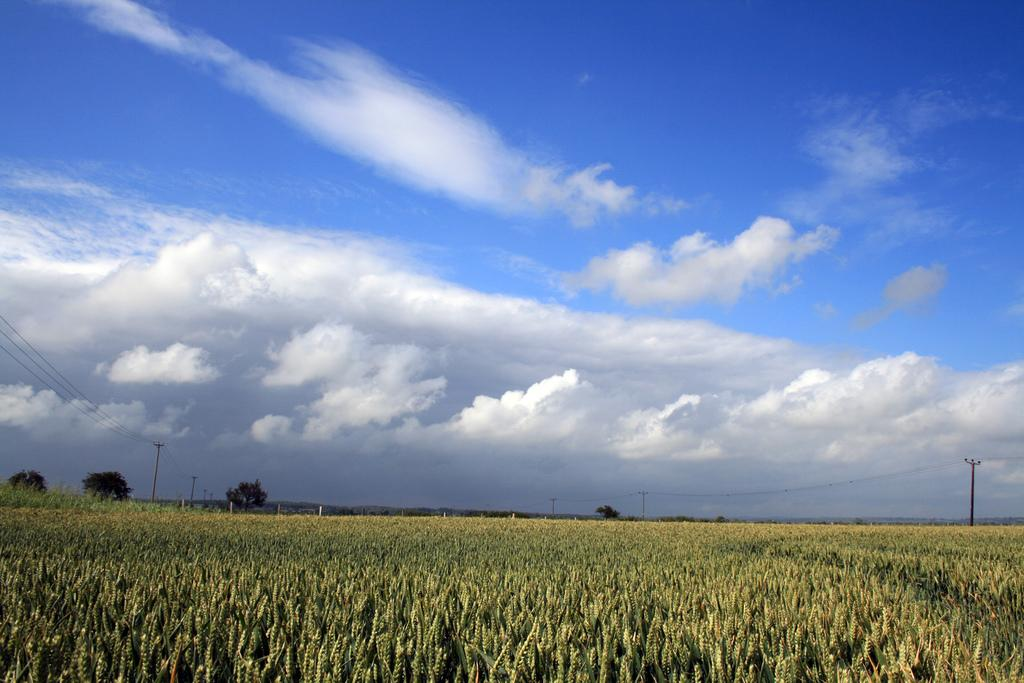What type of landscape is at the bottom of the image? There is a field at the bottom of the image. What can be seen in the background of the image? There are trees, poles, and hills in the background of the image. What else is visible in the image? Wires are visible in the image. What part of the natural environment is visible in the image? The sky is visible in the image. Where is the pail located in the image? There is no pail present in the image. What type of stove is visible in the image? There is no stove present in the image. 